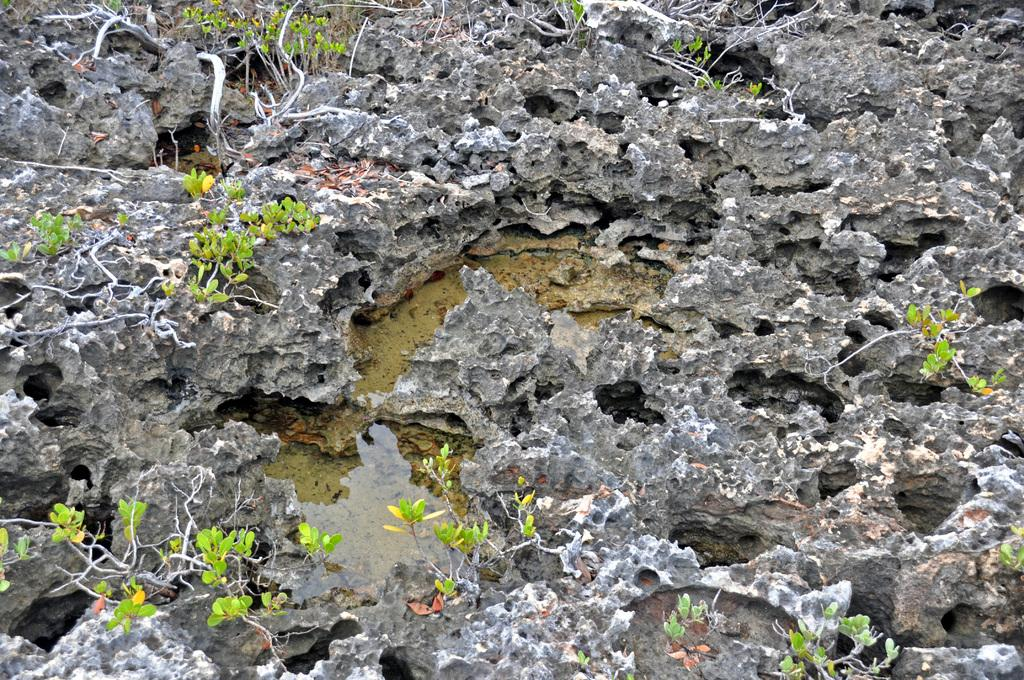What type of living organisms can be seen in the image? Plants can be seen in the image. What type of natural formation is present in the image? Rocks can be seen in the image. What can be seen in the image that might suggest a water source? Water is visible in the image. Can you tell me how many zebras are grazing near the plants in the image? There are no zebras present in the image; it features plants and rocks. What type of cooking equipment can be seen in the image? There is no cooking equipment present in the image. 